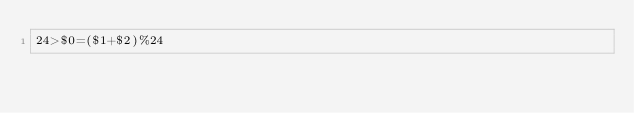Convert code to text. <code><loc_0><loc_0><loc_500><loc_500><_Awk_>24>$0=($1+$2)%24</code> 